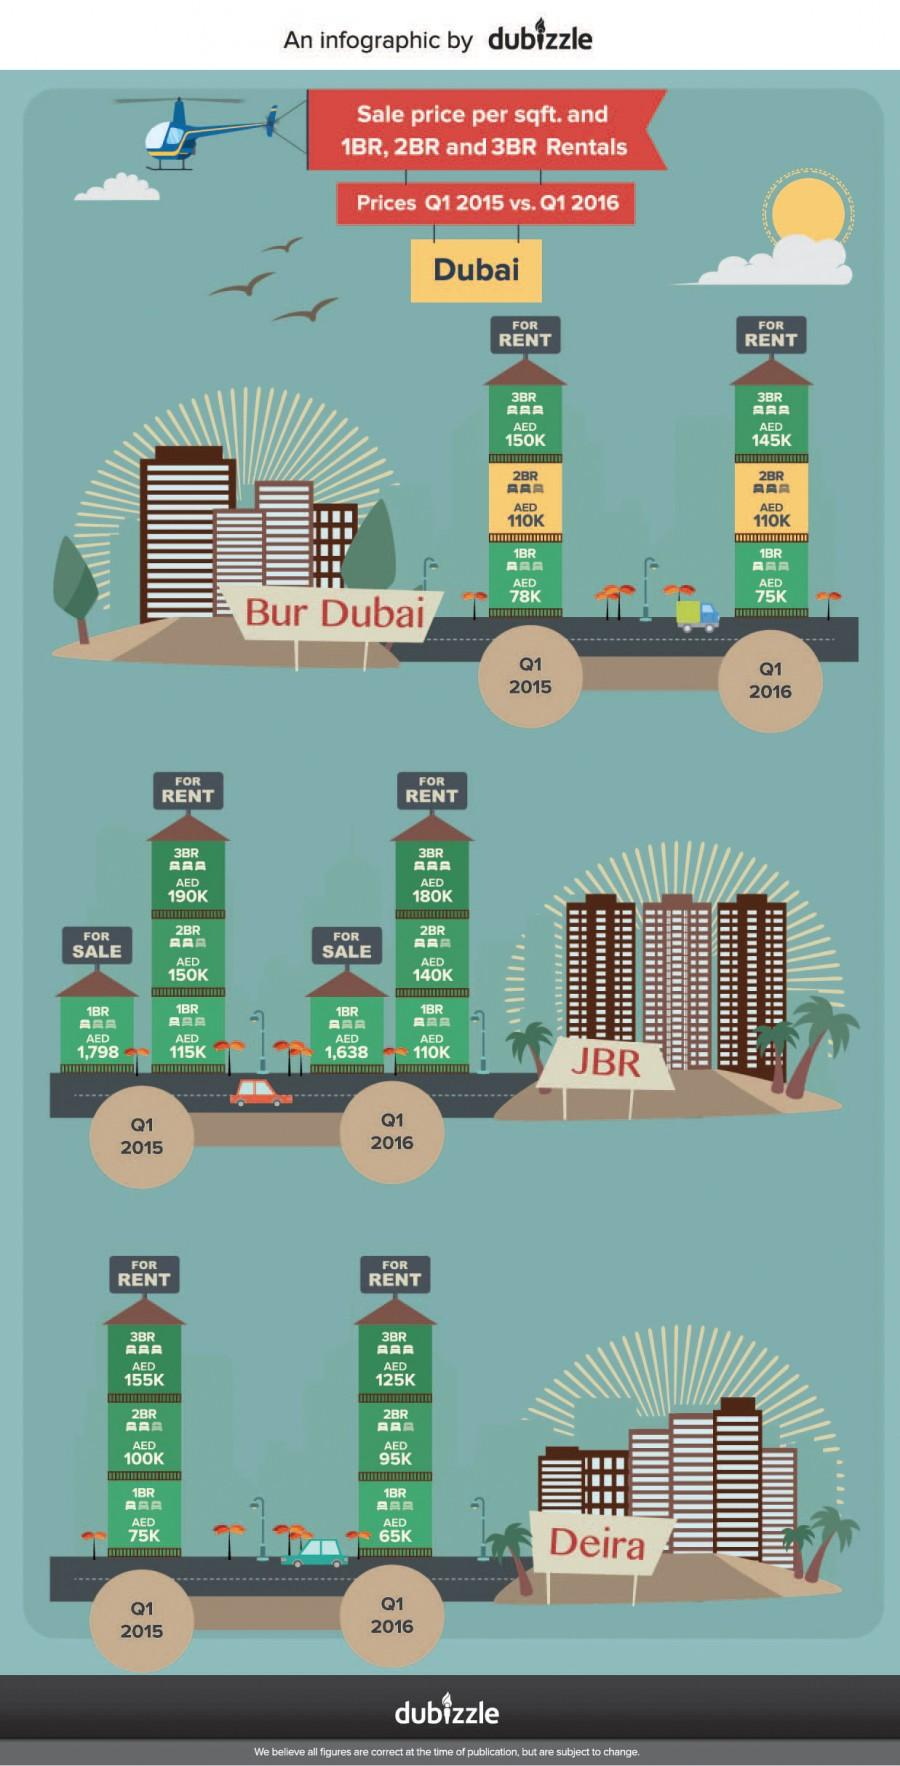Identify some key points in this picture. The sales price for a single bedroom apartment in JBR, Dubai during the first quarter of 2016 was the lowest among all years. In the first quarter of 2016, the sales price per square foot for a one-bedroom apartment in Jumeirah Beach Residence (JBR), Dubai was AED 1,638. According to data from Q1 2016, the average rent price for a three-bedroom apartment in Bur Dubai was approximately AED 145,000. In Q1 2015, the sales price per square foot for a one-bedroom apartment in JBR, Dubai was AED 1,798. In the first quarter of 2015, the highest rent price for a double bedroom apartment was recorded in Deira, Dubai. 